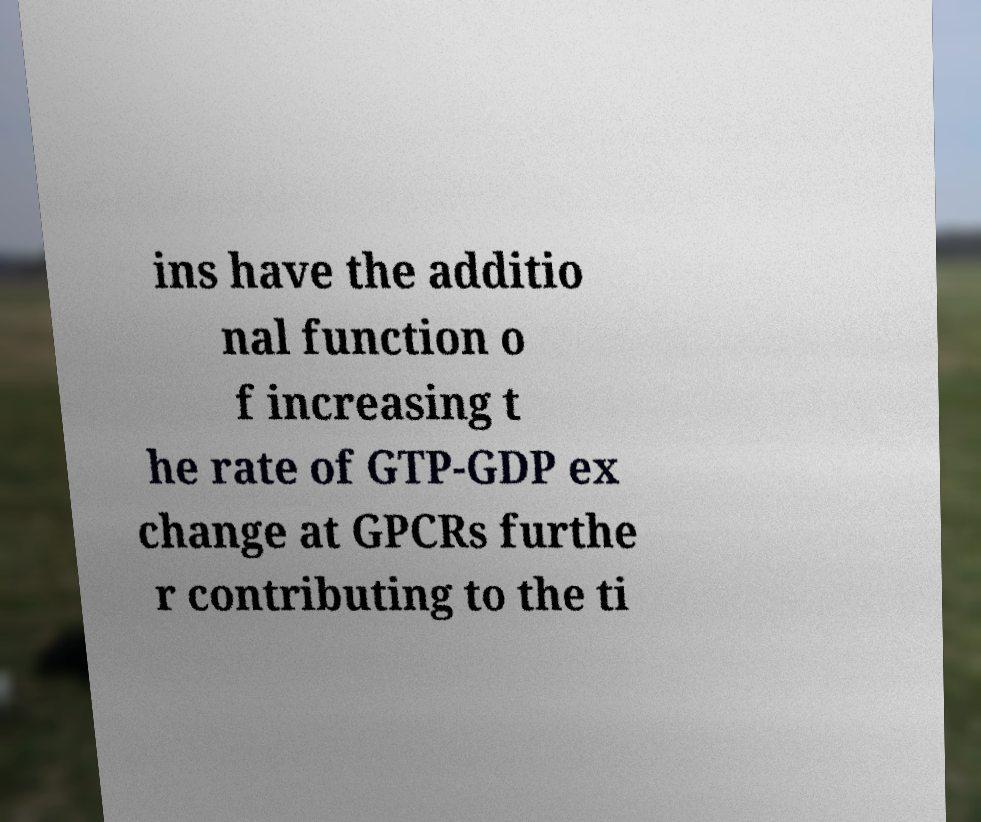There's text embedded in this image that I need extracted. Can you transcribe it verbatim? ins have the additio nal function o f increasing t he rate of GTP-GDP ex change at GPCRs furthe r contributing to the ti 